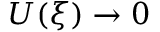Convert formula to latex. <formula><loc_0><loc_0><loc_500><loc_500>U ( \xi ) \to 0</formula> 